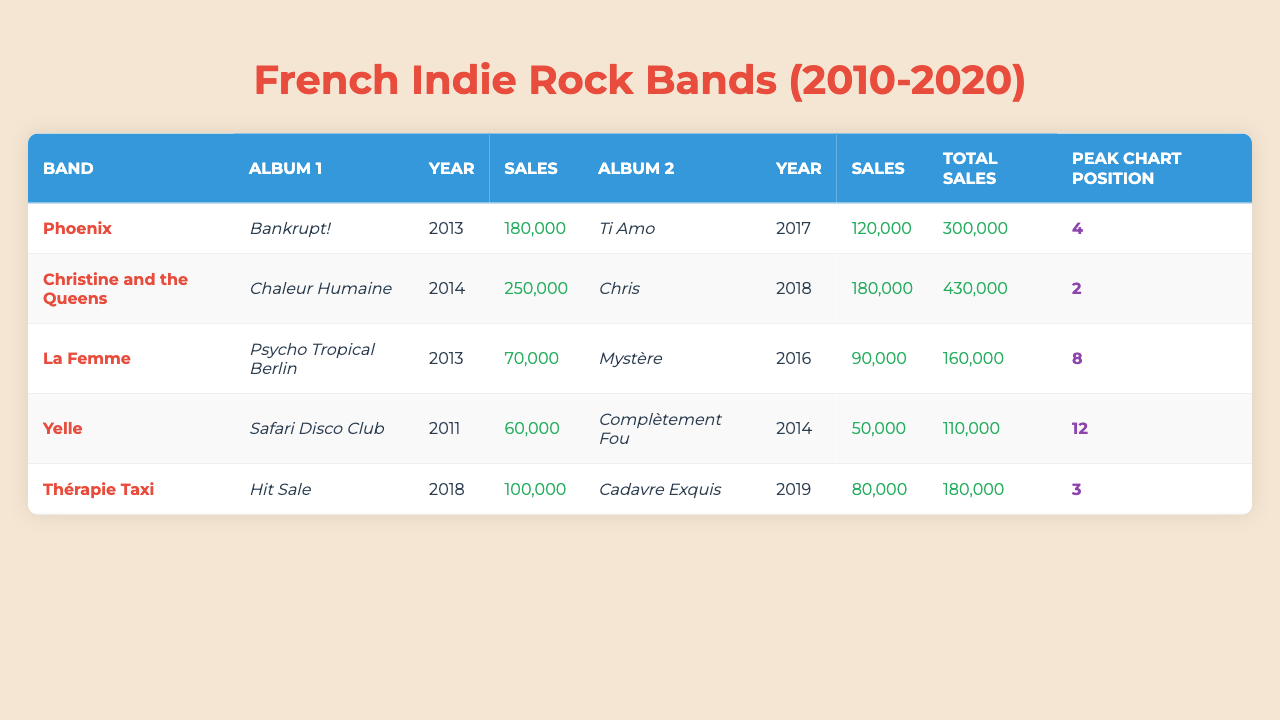What is the total sales for Christine and the Queens? The total sales for Christine and the Queens are listed in the "Total Sales" column, which shows 430,000.
Answer: 430,000 Which band has the highest total sales? By comparing the total sales values in the "Total Sales" column, Christine and the Queens has the highest total sales of 430,000.
Answer: Christine and the Queens Did La Femme's album "Psycho Tropical Berlin" have higher sales than Yelle's album "Safari Disco Club"? "Psycho Tropical Berlin" sold 70,000 copies while "Safari Disco Club" sold 60,000 copies, making "Psycho Tropical Berlin" higher in sales.
Answer: Yes What are the total sales of both albums for Phoenix? The sales for Phoenix's albums "Bankrupt!" and "Ti Amo" are 180,000 and 120,000 respectively. Adding these gives 180,000 + 120,000 = 300,000.
Answer: 300,000 Which band had a peak chart position of 3? The peak chart position can be found in the "Peak Chart Position" column. Thérapie Taxi is listed with a peak chart position of 3.
Answer: Thérapie Taxi How many sales did Yelle's two albums achieve in total? The two albums "Safari Disco Club" and "Complètement Fou" had sales of 60,000 and 50,000 respectively. The total is 60,000 + 50,000 = 110,000.
Answer: 110,000 Which band had the lowest total sales, and what was the amount? By reviewing the total sales column, La Femme has the lowest total sales of 160,000.
Answer: La Femme, 160,000 What is the average peak chart position for all bands? The peak chart positions are 4, 2, 8, 12, and 3. Summing these gives 4 + 2 + 8 + 12 + 3 = 29. There are 5 entries, so the average is 29/5 = 5.8.
Answer: 5.8 What was the highest selling album by Christine and the Queens, and how many copies did it sell? The album "Chaleur Humaine" sold 250,000 copies, which is the highest among Christine and the Queens' albums as shown in the sales data.
Answer: "Chaleur Humaine", 250,000 Which band released albums in both 2013 and 2018? The bands can be checked for albums released in 2013 and 2018. Phoenix and Christine and the Queens released albums in those years.
Answer: Phoenix, Christine and the Queens 